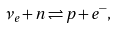<formula> <loc_0><loc_0><loc_500><loc_500>\nu _ { e } + n \rightleftharpoons p + e ^ { - } ,</formula> 